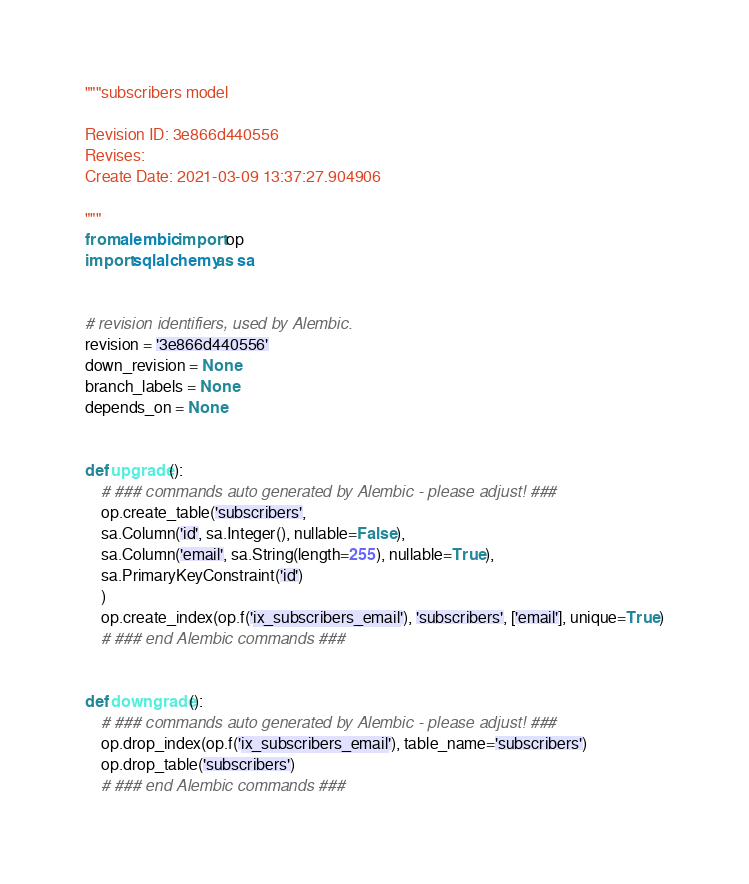<code> <loc_0><loc_0><loc_500><loc_500><_Python_>"""subscribers model

Revision ID: 3e866d440556
Revises: 
Create Date: 2021-03-09 13:37:27.904906

"""
from alembic import op
import sqlalchemy as sa


# revision identifiers, used by Alembic.
revision = '3e866d440556'
down_revision = None
branch_labels = None
depends_on = None


def upgrade():
    # ### commands auto generated by Alembic - please adjust! ###
    op.create_table('subscribers',
    sa.Column('id', sa.Integer(), nullable=False),
    sa.Column('email', sa.String(length=255), nullable=True),
    sa.PrimaryKeyConstraint('id')
    )
    op.create_index(op.f('ix_subscribers_email'), 'subscribers', ['email'], unique=True)
    # ### end Alembic commands ###


def downgrade():
    # ### commands auto generated by Alembic - please adjust! ###
    op.drop_index(op.f('ix_subscribers_email'), table_name='subscribers')
    op.drop_table('subscribers')
    # ### end Alembic commands ###
</code> 